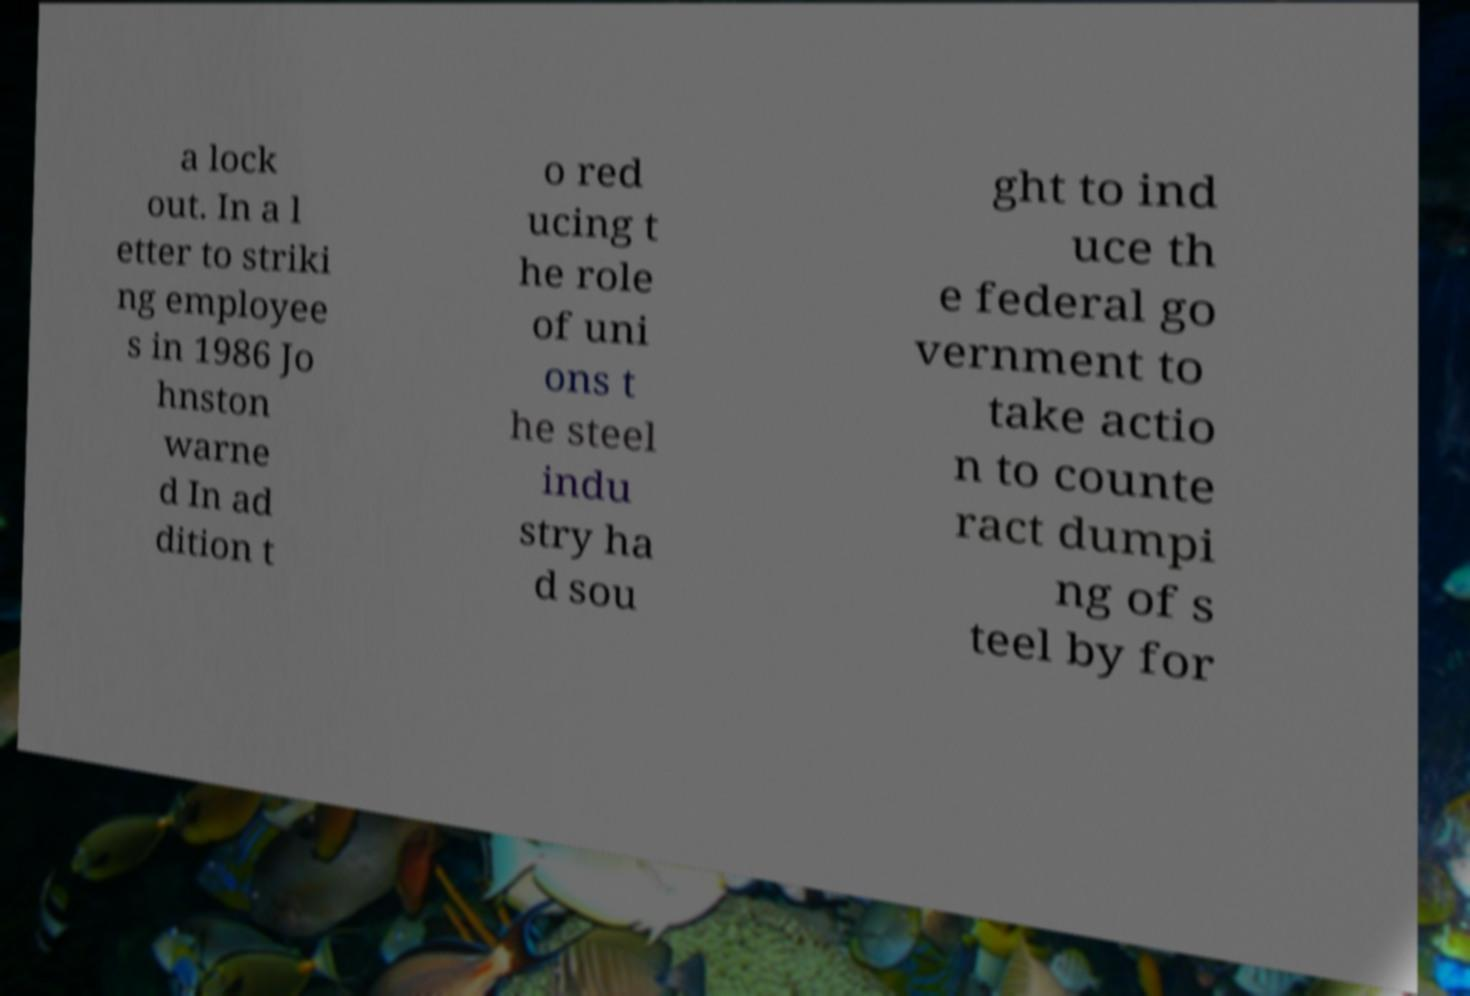Please read and relay the text visible in this image. What does it say? a lock out. In a l etter to striki ng employee s in 1986 Jo hnston warne d In ad dition t o red ucing t he role of uni ons t he steel indu stry ha d sou ght to ind uce th e federal go vernment to take actio n to counte ract dumpi ng of s teel by for 